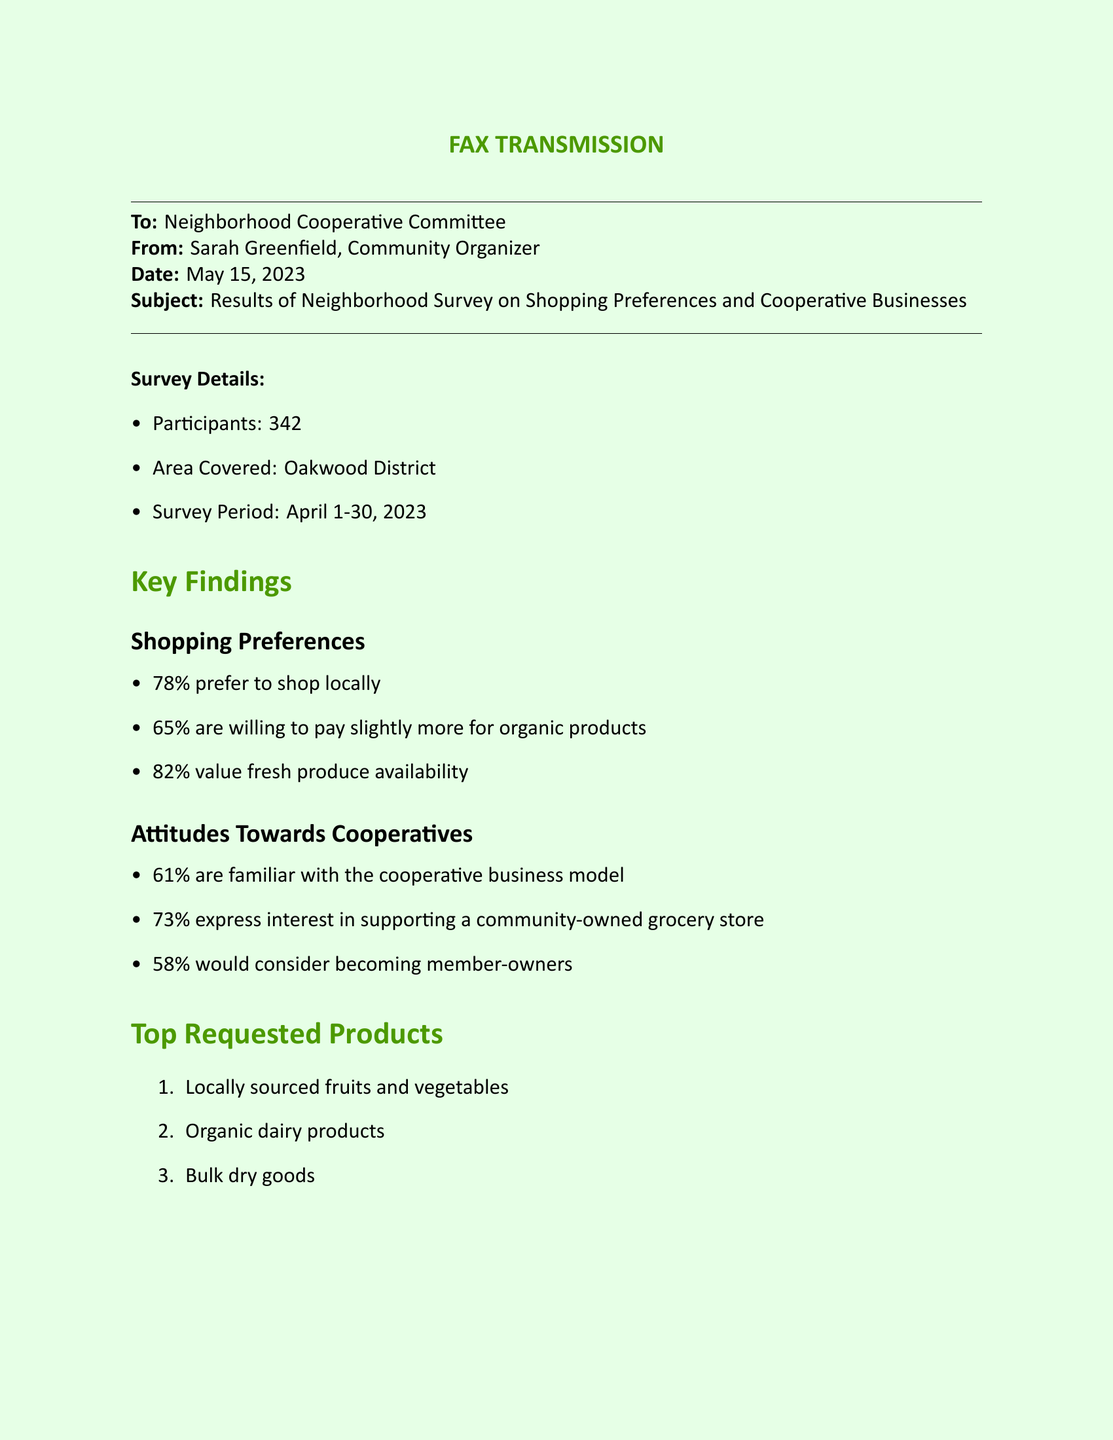What percentage of participants prefer to shop locally? The document states that 78% of participants prefer to shop locally.
Answer: 78% What is the area covered by the survey? The area covered by the survey is mentioned as Oakwood District.
Answer: Oakwood District How many participants expressed interest in supporting a community-owned grocery store? The document indicates that 73% of participants express interest in supporting a community-owned grocery store, which relates to the number of participants.
Answer: 250 What are the top requested products? The top requested products are listed as locally sourced fruits and vegetables, organic dairy products, and bulk dry goods.
Answer: Locally sourced fruits and vegetables, organic dairy products, bulk dry goods When will the community meeting take place? The document specifies that the community meeting is scheduled for June 1st.
Answer: June 1st What is the main purpose of the fax? The fax outlines results of a neighborhood survey on shopping preferences and cooperative businesses.
Answer: Results of Neighborhood Survey What percentage of participants are familiar with the cooperative business model? The document states that 61% of participants are familiar with the cooperative business model.
Answer: 61% What is one community benefit mentioned in the document? The document lists several community benefits, one of which is job creation for local residents.
Answer: Job creation for local residents How many surveys were conducted in total? The number of participants surveyed is recorded as 342.
Answer: 342 